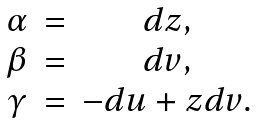Convert formula to latex. <formula><loc_0><loc_0><loc_500><loc_500>\begin{array} { c c c } \alpha & = & d z , \\ \beta & = & d v , \\ \gamma & = & - d u + z d v . \end{array}</formula> 